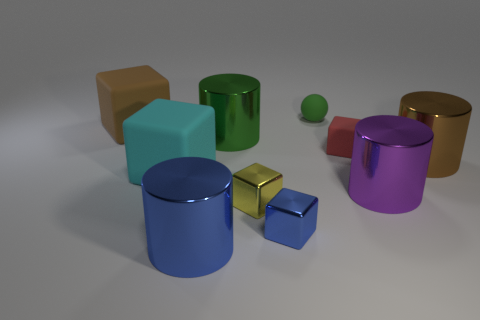Subtract all big green cylinders. How many cylinders are left? 3 Subtract all spheres. How many objects are left? 9 Subtract all blue cylinders. How many cylinders are left? 3 Subtract all yellow spheres. Subtract all red cylinders. How many spheres are left? 1 Subtract all small gray shiny things. Subtract all cyan objects. How many objects are left? 9 Add 9 yellow shiny cubes. How many yellow shiny cubes are left? 10 Add 6 big green shiny cylinders. How many big green shiny cylinders exist? 7 Subtract 1 cyan blocks. How many objects are left? 9 Subtract 2 cylinders. How many cylinders are left? 2 